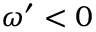Convert formula to latex. <formula><loc_0><loc_0><loc_500><loc_500>\omega ^ { \prime } < 0</formula> 